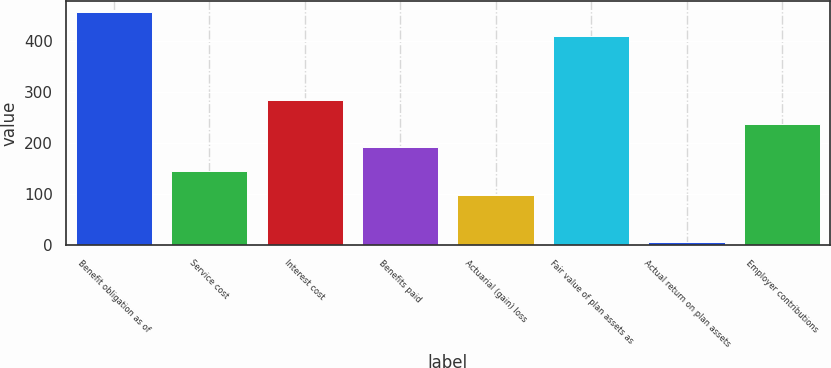<chart> <loc_0><loc_0><loc_500><loc_500><bar_chart><fcel>Benefit obligation as of<fcel>Service cost<fcel>Interest cost<fcel>Benefits paid<fcel>Actuarial (gain) loss<fcel>Fair value of plan assets as<fcel>Actual return on plan assets<fcel>Employer contributions<nl><fcel>456.4<fcel>145.2<fcel>284.4<fcel>191.6<fcel>98.8<fcel>410<fcel>6<fcel>238<nl></chart> 